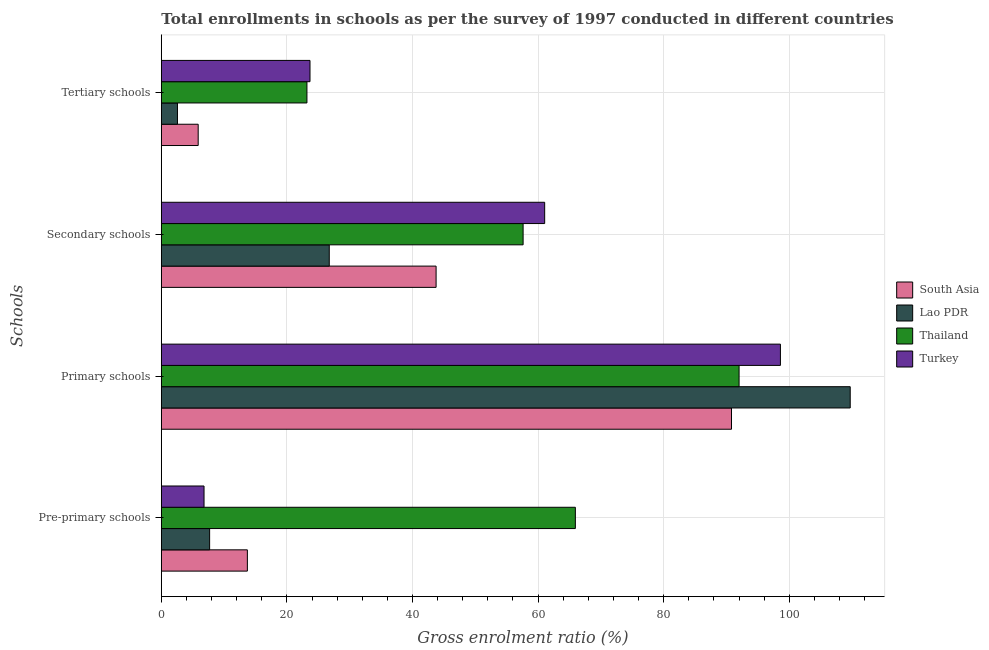How many different coloured bars are there?
Provide a succinct answer. 4. How many groups of bars are there?
Provide a succinct answer. 4. Are the number of bars per tick equal to the number of legend labels?
Ensure brevity in your answer.  Yes. Are the number of bars on each tick of the Y-axis equal?
Offer a terse response. Yes. What is the label of the 2nd group of bars from the top?
Your answer should be very brief. Secondary schools. What is the gross enrolment ratio in pre-primary schools in Thailand?
Your answer should be compact. 65.94. Across all countries, what is the maximum gross enrolment ratio in tertiary schools?
Make the answer very short. 23.68. Across all countries, what is the minimum gross enrolment ratio in primary schools?
Offer a terse response. 90.81. In which country was the gross enrolment ratio in secondary schools maximum?
Provide a short and direct response. Turkey. What is the total gross enrolment ratio in primary schools in the graph?
Give a very brief answer. 391.13. What is the difference between the gross enrolment ratio in pre-primary schools in Lao PDR and that in South Asia?
Give a very brief answer. -6.01. What is the difference between the gross enrolment ratio in tertiary schools in Lao PDR and the gross enrolment ratio in pre-primary schools in Thailand?
Provide a short and direct response. -63.37. What is the average gross enrolment ratio in primary schools per country?
Your answer should be very brief. 97.78. What is the difference between the gross enrolment ratio in secondary schools and gross enrolment ratio in primary schools in Lao PDR?
Your answer should be compact. -82.97. What is the ratio of the gross enrolment ratio in secondary schools in Lao PDR to that in Thailand?
Give a very brief answer. 0.46. Is the gross enrolment ratio in primary schools in Lao PDR less than that in Turkey?
Keep it short and to the point. No. Is the difference between the gross enrolment ratio in pre-primary schools in Turkey and Thailand greater than the difference between the gross enrolment ratio in tertiary schools in Turkey and Thailand?
Provide a short and direct response. No. What is the difference between the highest and the second highest gross enrolment ratio in tertiary schools?
Provide a succinct answer. 0.49. What is the difference between the highest and the lowest gross enrolment ratio in primary schools?
Provide a succinct answer. 18.91. What does the 4th bar from the top in Pre-primary schools represents?
Your response must be concise. South Asia. What does the 3rd bar from the bottom in Primary schools represents?
Make the answer very short. Thailand. Is it the case that in every country, the sum of the gross enrolment ratio in pre-primary schools and gross enrolment ratio in primary schools is greater than the gross enrolment ratio in secondary schools?
Provide a succinct answer. Yes. How many bars are there?
Make the answer very short. 16. How many countries are there in the graph?
Provide a succinct answer. 4. How are the legend labels stacked?
Your response must be concise. Vertical. What is the title of the graph?
Make the answer very short. Total enrollments in schools as per the survey of 1997 conducted in different countries. What is the label or title of the X-axis?
Ensure brevity in your answer.  Gross enrolment ratio (%). What is the label or title of the Y-axis?
Keep it short and to the point. Schools. What is the Gross enrolment ratio (%) of South Asia in Pre-primary schools?
Your answer should be compact. 13.7. What is the Gross enrolment ratio (%) in Lao PDR in Pre-primary schools?
Your response must be concise. 7.69. What is the Gross enrolment ratio (%) in Thailand in Pre-primary schools?
Make the answer very short. 65.94. What is the Gross enrolment ratio (%) of Turkey in Pre-primary schools?
Your answer should be compact. 6.8. What is the Gross enrolment ratio (%) in South Asia in Primary schools?
Keep it short and to the point. 90.81. What is the Gross enrolment ratio (%) in Lao PDR in Primary schools?
Offer a terse response. 109.71. What is the Gross enrolment ratio (%) in Thailand in Primary schools?
Your answer should be very brief. 92.01. What is the Gross enrolment ratio (%) in Turkey in Primary schools?
Keep it short and to the point. 98.6. What is the Gross enrolment ratio (%) of South Asia in Secondary schools?
Keep it short and to the point. 43.76. What is the Gross enrolment ratio (%) in Lao PDR in Secondary schools?
Offer a very short reply. 26.75. What is the Gross enrolment ratio (%) in Thailand in Secondary schools?
Keep it short and to the point. 57.62. What is the Gross enrolment ratio (%) in Turkey in Secondary schools?
Offer a very short reply. 61.05. What is the Gross enrolment ratio (%) in South Asia in Tertiary schools?
Your response must be concise. 5.87. What is the Gross enrolment ratio (%) in Lao PDR in Tertiary schools?
Your answer should be very brief. 2.57. What is the Gross enrolment ratio (%) of Thailand in Tertiary schools?
Keep it short and to the point. 23.19. What is the Gross enrolment ratio (%) in Turkey in Tertiary schools?
Give a very brief answer. 23.68. Across all Schools, what is the maximum Gross enrolment ratio (%) of South Asia?
Offer a terse response. 90.81. Across all Schools, what is the maximum Gross enrolment ratio (%) of Lao PDR?
Give a very brief answer. 109.71. Across all Schools, what is the maximum Gross enrolment ratio (%) of Thailand?
Provide a succinct answer. 92.01. Across all Schools, what is the maximum Gross enrolment ratio (%) of Turkey?
Make the answer very short. 98.6. Across all Schools, what is the minimum Gross enrolment ratio (%) of South Asia?
Provide a succinct answer. 5.87. Across all Schools, what is the minimum Gross enrolment ratio (%) in Lao PDR?
Your answer should be compact. 2.57. Across all Schools, what is the minimum Gross enrolment ratio (%) of Thailand?
Keep it short and to the point. 23.19. Across all Schools, what is the minimum Gross enrolment ratio (%) of Turkey?
Provide a short and direct response. 6.8. What is the total Gross enrolment ratio (%) in South Asia in the graph?
Provide a short and direct response. 154.14. What is the total Gross enrolment ratio (%) in Lao PDR in the graph?
Offer a terse response. 146.73. What is the total Gross enrolment ratio (%) of Thailand in the graph?
Offer a terse response. 238.76. What is the total Gross enrolment ratio (%) in Turkey in the graph?
Keep it short and to the point. 190.13. What is the difference between the Gross enrolment ratio (%) in South Asia in Pre-primary schools and that in Primary schools?
Make the answer very short. -77.1. What is the difference between the Gross enrolment ratio (%) in Lao PDR in Pre-primary schools and that in Primary schools?
Make the answer very short. -102.02. What is the difference between the Gross enrolment ratio (%) of Thailand in Pre-primary schools and that in Primary schools?
Make the answer very short. -26.07. What is the difference between the Gross enrolment ratio (%) of Turkey in Pre-primary schools and that in Primary schools?
Offer a terse response. -91.79. What is the difference between the Gross enrolment ratio (%) of South Asia in Pre-primary schools and that in Secondary schools?
Your answer should be very brief. -30.06. What is the difference between the Gross enrolment ratio (%) of Lao PDR in Pre-primary schools and that in Secondary schools?
Your answer should be very brief. -19.05. What is the difference between the Gross enrolment ratio (%) in Thailand in Pre-primary schools and that in Secondary schools?
Offer a very short reply. 8.32. What is the difference between the Gross enrolment ratio (%) of Turkey in Pre-primary schools and that in Secondary schools?
Make the answer very short. -54.25. What is the difference between the Gross enrolment ratio (%) of South Asia in Pre-primary schools and that in Tertiary schools?
Your response must be concise. 7.83. What is the difference between the Gross enrolment ratio (%) of Lao PDR in Pre-primary schools and that in Tertiary schools?
Your answer should be very brief. 5.12. What is the difference between the Gross enrolment ratio (%) of Thailand in Pre-primary schools and that in Tertiary schools?
Provide a short and direct response. 42.75. What is the difference between the Gross enrolment ratio (%) in Turkey in Pre-primary schools and that in Tertiary schools?
Make the answer very short. -16.88. What is the difference between the Gross enrolment ratio (%) of South Asia in Primary schools and that in Secondary schools?
Offer a very short reply. 47.05. What is the difference between the Gross enrolment ratio (%) of Lao PDR in Primary schools and that in Secondary schools?
Provide a succinct answer. 82.97. What is the difference between the Gross enrolment ratio (%) of Thailand in Primary schools and that in Secondary schools?
Provide a short and direct response. 34.39. What is the difference between the Gross enrolment ratio (%) of Turkey in Primary schools and that in Secondary schools?
Give a very brief answer. 37.54. What is the difference between the Gross enrolment ratio (%) in South Asia in Primary schools and that in Tertiary schools?
Your answer should be compact. 84.93. What is the difference between the Gross enrolment ratio (%) in Lao PDR in Primary schools and that in Tertiary schools?
Your answer should be very brief. 107.14. What is the difference between the Gross enrolment ratio (%) of Thailand in Primary schools and that in Tertiary schools?
Your response must be concise. 68.82. What is the difference between the Gross enrolment ratio (%) of Turkey in Primary schools and that in Tertiary schools?
Provide a short and direct response. 74.92. What is the difference between the Gross enrolment ratio (%) of South Asia in Secondary schools and that in Tertiary schools?
Provide a short and direct response. 37.89. What is the difference between the Gross enrolment ratio (%) of Lao PDR in Secondary schools and that in Tertiary schools?
Offer a terse response. 24.17. What is the difference between the Gross enrolment ratio (%) in Thailand in Secondary schools and that in Tertiary schools?
Ensure brevity in your answer.  34.43. What is the difference between the Gross enrolment ratio (%) of Turkey in Secondary schools and that in Tertiary schools?
Offer a terse response. 37.37. What is the difference between the Gross enrolment ratio (%) of South Asia in Pre-primary schools and the Gross enrolment ratio (%) of Lao PDR in Primary schools?
Keep it short and to the point. -96.01. What is the difference between the Gross enrolment ratio (%) in South Asia in Pre-primary schools and the Gross enrolment ratio (%) in Thailand in Primary schools?
Give a very brief answer. -78.31. What is the difference between the Gross enrolment ratio (%) of South Asia in Pre-primary schools and the Gross enrolment ratio (%) of Turkey in Primary schools?
Your response must be concise. -84.89. What is the difference between the Gross enrolment ratio (%) in Lao PDR in Pre-primary schools and the Gross enrolment ratio (%) in Thailand in Primary schools?
Your answer should be very brief. -84.32. What is the difference between the Gross enrolment ratio (%) in Lao PDR in Pre-primary schools and the Gross enrolment ratio (%) in Turkey in Primary schools?
Provide a short and direct response. -90.9. What is the difference between the Gross enrolment ratio (%) in Thailand in Pre-primary schools and the Gross enrolment ratio (%) in Turkey in Primary schools?
Offer a very short reply. -32.66. What is the difference between the Gross enrolment ratio (%) of South Asia in Pre-primary schools and the Gross enrolment ratio (%) of Lao PDR in Secondary schools?
Your answer should be compact. -13.04. What is the difference between the Gross enrolment ratio (%) of South Asia in Pre-primary schools and the Gross enrolment ratio (%) of Thailand in Secondary schools?
Keep it short and to the point. -43.91. What is the difference between the Gross enrolment ratio (%) in South Asia in Pre-primary schools and the Gross enrolment ratio (%) in Turkey in Secondary schools?
Provide a short and direct response. -47.35. What is the difference between the Gross enrolment ratio (%) of Lao PDR in Pre-primary schools and the Gross enrolment ratio (%) of Thailand in Secondary schools?
Provide a succinct answer. -49.93. What is the difference between the Gross enrolment ratio (%) of Lao PDR in Pre-primary schools and the Gross enrolment ratio (%) of Turkey in Secondary schools?
Provide a short and direct response. -53.36. What is the difference between the Gross enrolment ratio (%) of Thailand in Pre-primary schools and the Gross enrolment ratio (%) of Turkey in Secondary schools?
Make the answer very short. 4.89. What is the difference between the Gross enrolment ratio (%) of South Asia in Pre-primary schools and the Gross enrolment ratio (%) of Lao PDR in Tertiary schools?
Provide a succinct answer. 11.13. What is the difference between the Gross enrolment ratio (%) in South Asia in Pre-primary schools and the Gross enrolment ratio (%) in Thailand in Tertiary schools?
Provide a short and direct response. -9.49. What is the difference between the Gross enrolment ratio (%) in South Asia in Pre-primary schools and the Gross enrolment ratio (%) in Turkey in Tertiary schools?
Ensure brevity in your answer.  -9.97. What is the difference between the Gross enrolment ratio (%) in Lao PDR in Pre-primary schools and the Gross enrolment ratio (%) in Thailand in Tertiary schools?
Ensure brevity in your answer.  -15.5. What is the difference between the Gross enrolment ratio (%) of Lao PDR in Pre-primary schools and the Gross enrolment ratio (%) of Turkey in Tertiary schools?
Provide a short and direct response. -15.99. What is the difference between the Gross enrolment ratio (%) of Thailand in Pre-primary schools and the Gross enrolment ratio (%) of Turkey in Tertiary schools?
Your answer should be very brief. 42.26. What is the difference between the Gross enrolment ratio (%) of South Asia in Primary schools and the Gross enrolment ratio (%) of Lao PDR in Secondary schools?
Ensure brevity in your answer.  64.06. What is the difference between the Gross enrolment ratio (%) of South Asia in Primary schools and the Gross enrolment ratio (%) of Thailand in Secondary schools?
Provide a succinct answer. 33.19. What is the difference between the Gross enrolment ratio (%) in South Asia in Primary schools and the Gross enrolment ratio (%) in Turkey in Secondary schools?
Make the answer very short. 29.75. What is the difference between the Gross enrolment ratio (%) in Lao PDR in Primary schools and the Gross enrolment ratio (%) in Thailand in Secondary schools?
Give a very brief answer. 52.09. What is the difference between the Gross enrolment ratio (%) in Lao PDR in Primary schools and the Gross enrolment ratio (%) in Turkey in Secondary schools?
Your answer should be compact. 48.66. What is the difference between the Gross enrolment ratio (%) in Thailand in Primary schools and the Gross enrolment ratio (%) in Turkey in Secondary schools?
Provide a short and direct response. 30.96. What is the difference between the Gross enrolment ratio (%) in South Asia in Primary schools and the Gross enrolment ratio (%) in Lao PDR in Tertiary schools?
Offer a very short reply. 88.23. What is the difference between the Gross enrolment ratio (%) of South Asia in Primary schools and the Gross enrolment ratio (%) of Thailand in Tertiary schools?
Provide a succinct answer. 67.62. What is the difference between the Gross enrolment ratio (%) of South Asia in Primary schools and the Gross enrolment ratio (%) of Turkey in Tertiary schools?
Offer a very short reply. 67.13. What is the difference between the Gross enrolment ratio (%) of Lao PDR in Primary schools and the Gross enrolment ratio (%) of Thailand in Tertiary schools?
Keep it short and to the point. 86.52. What is the difference between the Gross enrolment ratio (%) in Lao PDR in Primary schools and the Gross enrolment ratio (%) in Turkey in Tertiary schools?
Make the answer very short. 86.03. What is the difference between the Gross enrolment ratio (%) of Thailand in Primary schools and the Gross enrolment ratio (%) of Turkey in Tertiary schools?
Give a very brief answer. 68.33. What is the difference between the Gross enrolment ratio (%) of South Asia in Secondary schools and the Gross enrolment ratio (%) of Lao PDR in Tertiary schools?
Your response must be concise. 41.19. What is the difference between the Gross enrolment ratio (%) in South Asia in Secondary schools and the Gross enrolment ratio (%) in Thailand in Tertiary schools?
Offer a terse response. 20.57. What is the difference between the Gross enrolment ratio (%) in South Asia in Secondary schools and the Gross enrolment ratio (%) in Turkey in Tertiary schools?
Make the answer very short. 20.08. What is the difference between the Gross enrolment ratio (%) of Lao PDR in Secondary schools and the Gross enrolment ratio (%) of Thailand in Tertiary schools?
Offer a terse response. 3.56. What is the difference between the Gross enrolment ratio (%) of Lao PDR in Secondary schools and the Gross enrolment ratio (%) of Turkey in Tertiary schools?
Offer a very short reply. 3.07. What is the difference between the Gross enrolment ratio (%) of Thailand in Secondary schools and the Gross enrolment ratio (%) of Turkey in Tertiary schools?
Make the answer very short. 33.94. What is the average Gross enrolment ratio (%) of South Asia per Schools?
Give a very brief answer. 38.54. What is the average Gross enrolment ratio (%) of Lao PDR per Schools?
Offer a very short reply. 36.68. What is the average Gross enrolment ratio (%) of Thailand per Schools?
Provide a short and direct response. 59.69. What is the average Gross enrolment ratio (%) in Turkey per Schools?
Offer a very short reply. 47.53. What is the difference between the Gross enrolment ratio (%) in South Asia and Gross enrolment ratio (%) in Lao PDR in Pre-primary schools?
Keep it short and to the point. 6.01. What is the difference between the Gross enrolment ratio (%) in South Asia and Gross enrolment ratio (%) in Thailand in Pre-primary schools?
Give a very brief answer. -52.24. What is the difference between the Gross enrolment ratio (%) of South Asia and Gross enrolment ratio (%) of Turkey in Pre-primary schools?
Keep it short and to the point. 6.9. What is the difference between the Gross enrolment ratio (%) of Lao PDR and Gross enrolment ratio (%) of Thailand in Pre-primary schools?
Provide a short and direct response. -58.25. What is the difference between the Gross enrolment ratio (%) in Lao PDR and Gross enrolment ratio (%) in Turkey in Pre-primary schools?
Provide a short and direct response. 0.89. What is the difference between the Gross enrolment ratio (%) in Thailand and Gross enrolment ratio (%) in Turkey in Pre-primary schools?
Offer a terse response. 59.14. What is the difference between the Gross enrolment ratio (%) of South Asia and Gross enrolment ratio (%) of Lao PDR in Primary schools?
Give a very brief answer. -18.91. What is the difference between the Gross enrolment ratio (%) in South Asia and Gross enrolment ratio (%) in Thailand in Primary schools?
Your answer should be very brief. -1.21. What is the difference between the Gross enrolment ratio (%) in South Asia and Gross enrolment ratio (%) in Turkey in Primary schools?
Provide a short and direct response. -7.79. What is the difference between the Gross enrolment ratio (%) of Lao PDR and Gross enrolment ratio (%) of Thailand in Primary schools?
Ensure brevity in your answer.  17.7. What is the difference between the Gross enrolment ratio (%) of Lao PDR and Gross enrolment ratio (%) of Turkey in Primary schools?
Make the answer very short. 11.12. What is the difference between the Gross enrolment ratio (%) in Thailand and Gross enrolment ratio (%) in Turkey in Primary schools?
Give a very brief answer. -6.58. What is the difference between the Gross enrolment ratio (%) in South Asia and Gross enrolment ratio (%) in Lao PDR in Secondary schools?
Offer a terse response. 17.01. What is the difference between the Gross enrolment ratio (%) in South Asia and Gross enrolment ratio (%) in Thailand in Secondary schools?
Your response must be concise. -13.86. What is the difference between the Gross enrolment ratio (%) of South Asia and Gross enrolment ratio (%) of Turkey in Secondary schools?
Offer a very short reply. -17.29. What is the difference between the Gross enrolment ratio (%) in Lao PDR and Gross enrolment ratio (%) in Thailand in Secondary schools?
Your answer should be very brief. -30.87. What is the difference between the Gross enrolment ratio (%) of Lao PDR and Gross enrolment ratio (%) of Turkey in Secondary schools?
Give a very brief answer. -34.31. What is the difference between the Gross enrolment ratio (%) of Thailand and Gross enrolment ratio (%) of Turkey in Secondary schools?
Provide a short and direct response. -3.43. What is the difference between the Gross enrolment ratio (%) in South Asia and Gross enrolment ratio (%) in Lao PDR in Tertiary schools?
Ensure brevity in your answer.  3.3. What is the difference between the Gross enrolment ratio (%) in South Asia and Gross enrolment ratio (%) in Thailand in Tertiary schools?
Provide a short and direct response. -17.32. What is the difference between the Gross enrolment ratio (%) in South Asia and Gross enrolment ratio (%) in Turkey in Tertiary schools?
Make the answer very short. -17.81. What is the difference between the Gross enrolment ratio (%) in Lao PDR and Gross enrolment ratio (%) in Thailand in Tertiary schools?
Provide a succinct answer. -20.62. What is the difference between the Gross enrolment ratio (%) of Lao PDR and Gross enrolment ratio (%) of Turkey in Tertiary schools?
Your answer should be compact. -21.11. What is the difference between the Gross enrolment ratio (%) in Thailand and Gross enrolment ratio (%) in Turkey in Tertiary schools?
Make the answer very short. -0.49. What is the ratio of the Gross enrolment ratio (%) in South Asia in Pre-primary schools to that in Primary schools?
Provide a short and direct response. 0.15. What is the ratio of the Gross enrolment ratio (%) in Lao PDR in Pre-primary schools to that in Primary schools?
Ensure brevity in your answer.  0.07. What is the ratio of the Gross enrolment ratio (%) in Thailand in Pre-primary schools to that in Primary schools?
Give a very brief answer. 0.72. What is the ratio of the Gross enrolment ratio (%) in Turkey in Pre-primary schools to that in Primary schools?
Give a very brief answer. 0.07. What is the ratio of the Gross enrolment ratio (%) of South Asia in Pre-primary schools to that in Secondary schools?
Give a very brief answer. 0.31. What is the ratio of the Gross enrolment ratio (%) in Lao PDR in Pre-primary schools to that in Secondary schools?
Your answer should be compact. 0.29. What is the ratio of the Gross enrolment ratio (%) of Thailand in Pre-primary schools to that in Secondary schools?
Give a very brief answer. 1.14. What is the ratio of the Gross enrolment ratio (%) in Turkey in Pre-primary schools to that in Secondary schools?
Ensure brevity in your answer.  0.11. What is the ratio of the Gross enrolment ratio (%) in South Asia in Pre-primary schools to that in Tertiary schools?
Your answer should be compact. 2.33. What is the ratio of the Gross enrolment ratio (%) in Lao PDR in Pre-primary schools to that in Tertiary schools?
Your answer should be very brief. 2.99. What is the ratio of the Gross enrolment ratio (%) of Thailand in Pre-primary schools to that in Tertiary schools?
Provide a succinct answer. 2.84. What is the ratio of the Gross enrolment ratio (%) in Turkey in Pre-primary schools to that in Tertiary schools?
Provide a succinct answer. 0.29. What is the ratio of the Gross enrolment ratio (%) in South Asia in Primary schools to that in Secondary schools?
Give a very brief answer. 2.08. What is the ratio of the Gross enrolment ratio (%) of Lao PDR in Primary schools to that in Secondary schools?
Keep it short and to the point. 4.1. What is the ratio of the Gross enrolment ratio (%) of Thailand in Primary schools to that in Secondary schools?
Provide a short and direct response. 1.6. What is the ratio of the Gross enrolment ratio (%) in Turkey in Primary schools to that in Secondary schools?
Offer a very short reply. 1.61. What is the ratio of the Gross enrolment ratio (%) of South Asia in Primary schools to that in Tertiary schools?
Your response must be concise. 15.46. What is the ratio of the Gross enrolment ratio (%) in Lao PDR in Primary schools to that in Tertiary schools?
Provide a short and direct response. 42.64. What is the ratio of the Gross enrolment ratio (%) of Thailand in Primary schools to that in Tertiary schools?
Your answer should be compact. 3.97. What is the ratio of the Gross enrolment ratio (%) in Turkey in Primary schools to that in Tertiary schools?
Ensure brevity in your answer.  4.16. What is the ratio of the Gross enrolment ratio (%) in South Asia in Secondary schools to that in Tertiary schools?
Keep it short and to the point. 7.45. What is the ratio of the Gross enrolment ratio (%) of Lao PDR in Secondary schools to that in Tertiary schools?
Your answer should be very brief. 10.4. What is the ratio of the Gross enrolment ratio (%) of Thailand in Secondary schools to that in Tertiary schools?
Your answer should be compact. 2.48. What is the ratio of the Gross enrolment ratio (%) of Turkey in Secondary schools to that in Tertiary schools?
Offer a very short reply. 2.58. What is the difference between the highest and the second highest Gross enrolment ratio (%) in South Asia?
Your response must be concise. 47.05. What is the difference between the highest and the second highest Gross enrolment ratio (%) in Lao PDR?
Keep it short and to the point. 82.97. What is the difference between the highest and the second highest Gross enrolment ratio (%) of Thailand?
Give a very brief answer. 26.07. What is the difference between the highest and the second highest Gross enrolment ratio (%) in Turkey?
Ensure brevity in your answer.  37.54. What is the difference between the highest and the lowest Gross enrolment ratio (%) in South Asia?
Give a very brief answer. 84.93. What is the difference between the highest and the lowest Gross enrolment ratio (%) of Lao PDR?
Keep it short and to the point. 107.14. What is the difference between the highest and the lowest Gross enrolment ratio (%) in Thailand?
Your response must be concise. 68.82. What is the difference between the highest and the lowest Gross enrolment ratio (%) of Turkey?
Keep it short and to the point. 91.79. 